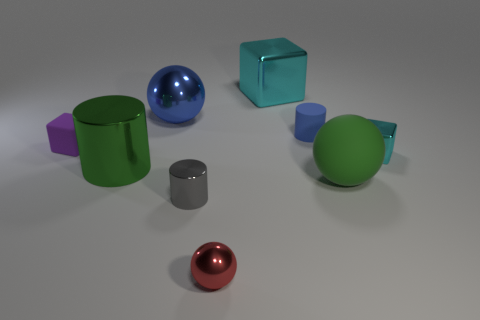Subtract all small blue cylinders. How many cylinders are left? 2 Subtract all green balls. How many balls are left? 2 Add 1 yellow matte spheres. How many objects exist? 10 Subtract all spheres. How many objects are left? 6 Subtract 2 blocks. How many blocks are left? 1 Subtract 1 blue spheres. How many objects are left? 8 Subtract all gray balls. Subtract all blue cubes. How many balls are left? 3 Subtract all brown balls. How many gray cylinders are left? 1 Subtract all shiny spheres. Subtract all small blue cubes. How many objects are left? 7 Add 9 small cyan things. How many small cyan things are left? 10 